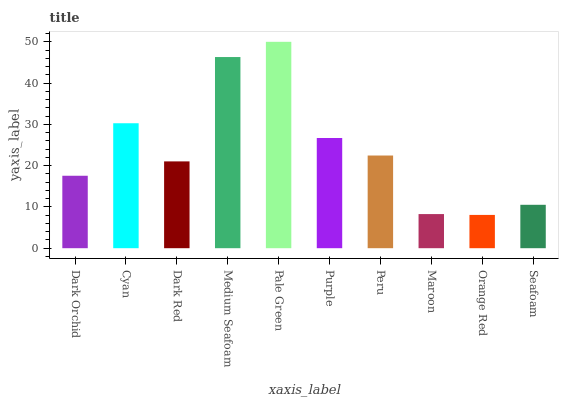Is Orange Red the minimum?
Answer yes or no. Yes. Is Pale Green the maximum?
Answer yes or no. Yes. Is Cyan the minimum?
Answer yes or no. No. Is Cyan the maximum?
Answer yes or no. No. Is Cyan greater than Dark Orchid?
Answer yes or no. Yes. Is Dark Orchid less than Cyan?
Answer yes or no. Yes. Is Dark Orchid greater than Cyan?
Answer yes or no. No. Is Cyan less than Dark Orchid?
Answer yes or no. No. Is Peru the high median?
Answer yes or no. Yes. Is Dark Red the low median?
Answer yes or no. Yes. Is Dark Orchid the high median?
Answer yes or no. No. Is Medium Seafoam the low median?
Answer yes or no. No. 